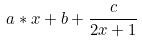<formula> <loc_0><loc_0><loc_500><loc_500>a * x + b + \frac { c } { 2 x + 1 }</formula> 